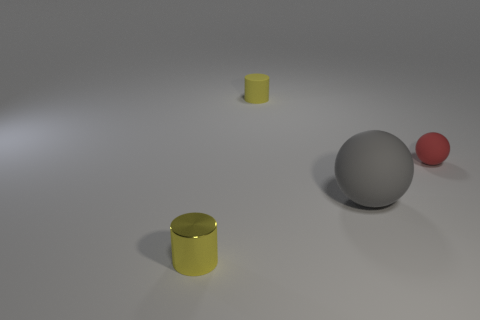Does the shadowing provide any clues about the light source? Yes, the shadows in the image suggest a single light source located above and to the right of the objects. The shadows are softer and diffused, which indicates the light source might be large or perhaps the environment has been set up to scatter the light, such as with a diffuser. 